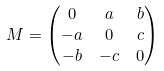Convert formula to latex. <formula><loc_0><loc_0><loc_500><loc_500>M & = \begin{pmatrix} 0 & a & b \\ - a & 0 & c \\ - b & - c & 0 \end{pmatrix}</formula> 